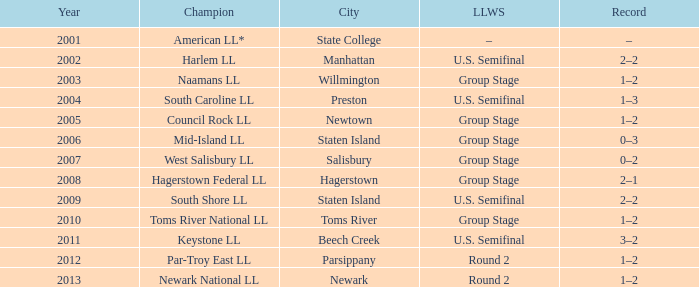In parsippany, which little league world series occurred? Round 2. 